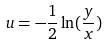<formula> <loc_0><loc_0><loc_500><loc_500>u = - \frac { 1 } { 2 } \ln ( \frac { y } { x } )</formula> 